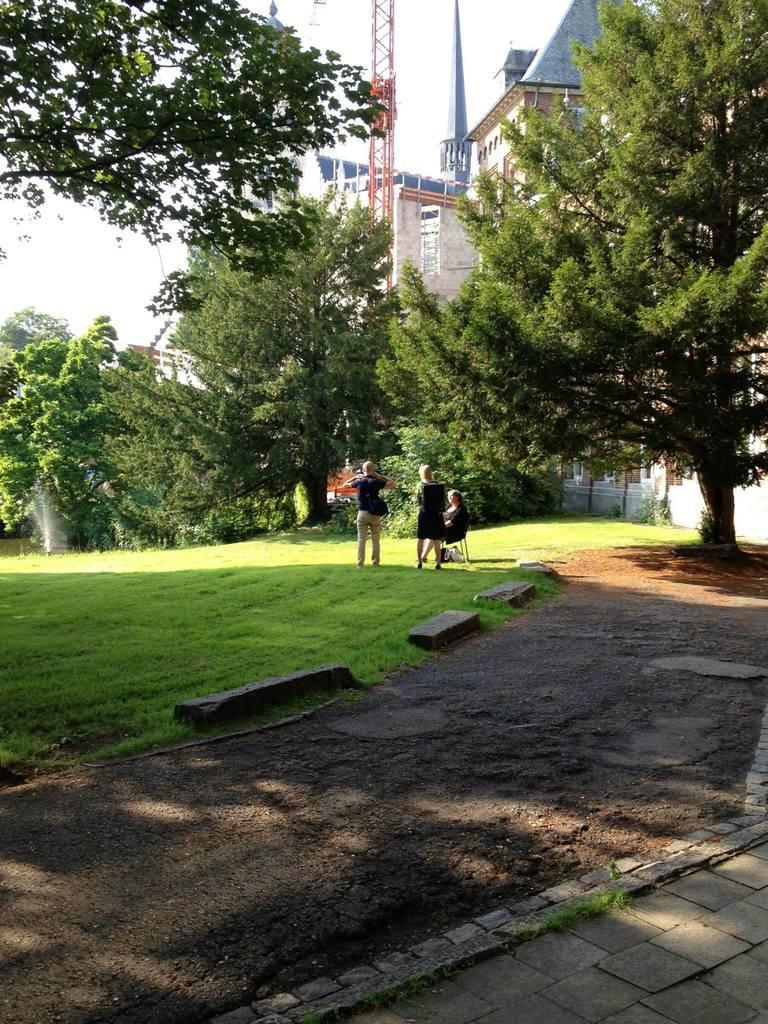Please provide a concise description of this image. In this image we can see a woman sitting and we can also see two persons standing. We can see the buildings, towers, trees, grass and also the path. We can also see the water. Sky is also visible in this image. 